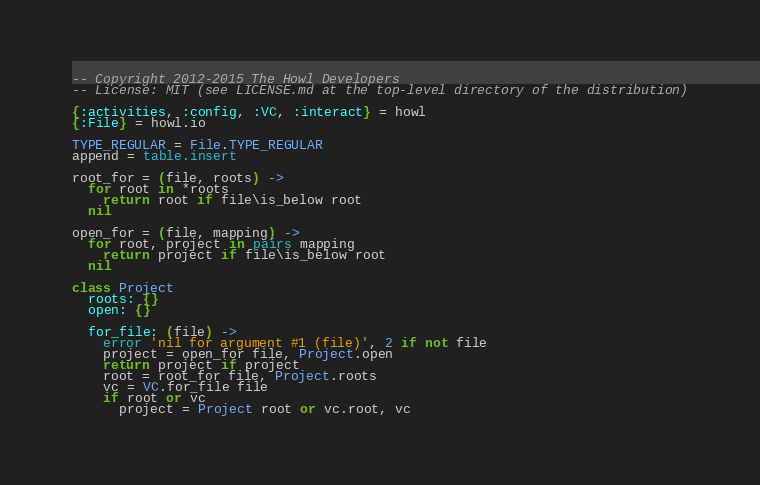<code> <loc_0><loc_0><loc_500><loc_500><_MoonScript_>-- Copyright 2012-2015 The Howl Developers
-- License: MIT (see LICENSE.md at the top-level directory of the distribution)

{:activities, :config, :VC, :interact} = howl
{:File} = howl.io

TYPE_REGULAR = File.TYPE_REGULAR
append = table.insert

root_for = (file, roots) ->
  for root in *roots
    return root if file\is_below root
  nil

open_for = (file, mapping) ->
  for root, project in pairs mapping
    return project if file\is_below root
  nil

class Project
  roots: {}
  open: {}

  for_file: (file) ->
    error 'nil for argument #1 (file)', 2 if not file
    project = open_for file, Project.open
    return project if project
    root = root_for file, Project.roots
    vc = VC.for_file file
    if root or vc
      project = Project root or vc.root, vc</code> 